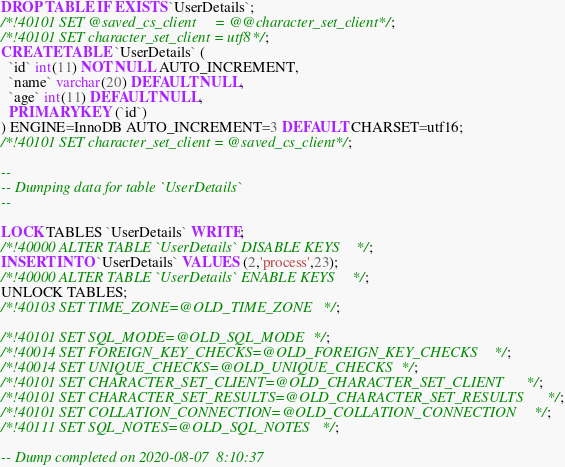<code> <loc_0><loc_0><loc_500><loc_500><_SQL_>DROP TABLE IF EXISTS `UserDetails`;
/*!40101 SET @saved_cs_client     = @@character_set_client */;
/*!40101 SET character_set_client = utf8 */;
CREATE TABLE `UserDetails` (
  `id` int(11) NOT NULL AUTO_INCREMENT,
  `name` varchar(20) DEFAULT NULL,
  `age` int(11) DEFAULT NULL,
  PRIMARY KEY (`id`)
) ENGINE=InnoDB AUTO_INCREMENT=3 DEFAULT CHARSET=utf16;
/*!40101 SET character_set_client = @saved_cs_client */;

--
-- Dumping data for table `UserDetails`
--

LOCK TABLES `UserDetails` WRITE;
/*!40000 ALTER TABLE `UserDetails` DISABLE KEYS */;
INSERT INTO `UserDetails` VALUES (2,'process',23);
/*!40000 ALTER TABLE `UserDetails` ENABLE KEYS */;
UNLOCK TABLES;
/*!40103 SET TIME_ZONE=@OLD_TIME_ZONE */;

/*!40101 SET SQL_MODE=@OLD_SQL_MODE */;
/*!40014 SET FOREIGN_KEY_CHECKS=@OLD_FOREIGN_KEY_CHECKS */;
/*!40014 SET UNIQUE_CHECKS=@OLD_UNIQUE_CHECKS */;
/*!40101 SET CHARACTER_SET_CLIENT=@OLD_CHARACTER_SET_CLIENT */;
/*!40101 SET CHARACTER_SET_RESULTS=@OLD_CHARACTER_SET_RESULTS */;
/*!40101 SET COLLATION_CONNECTION=@OLD_COLLATION_CONNECTION */;
/*!40111 SET SQL_NOTES=@OLD_SQL_NOTES */;

-- Dump completed on 2020-08-07  8:10:37
</code> 